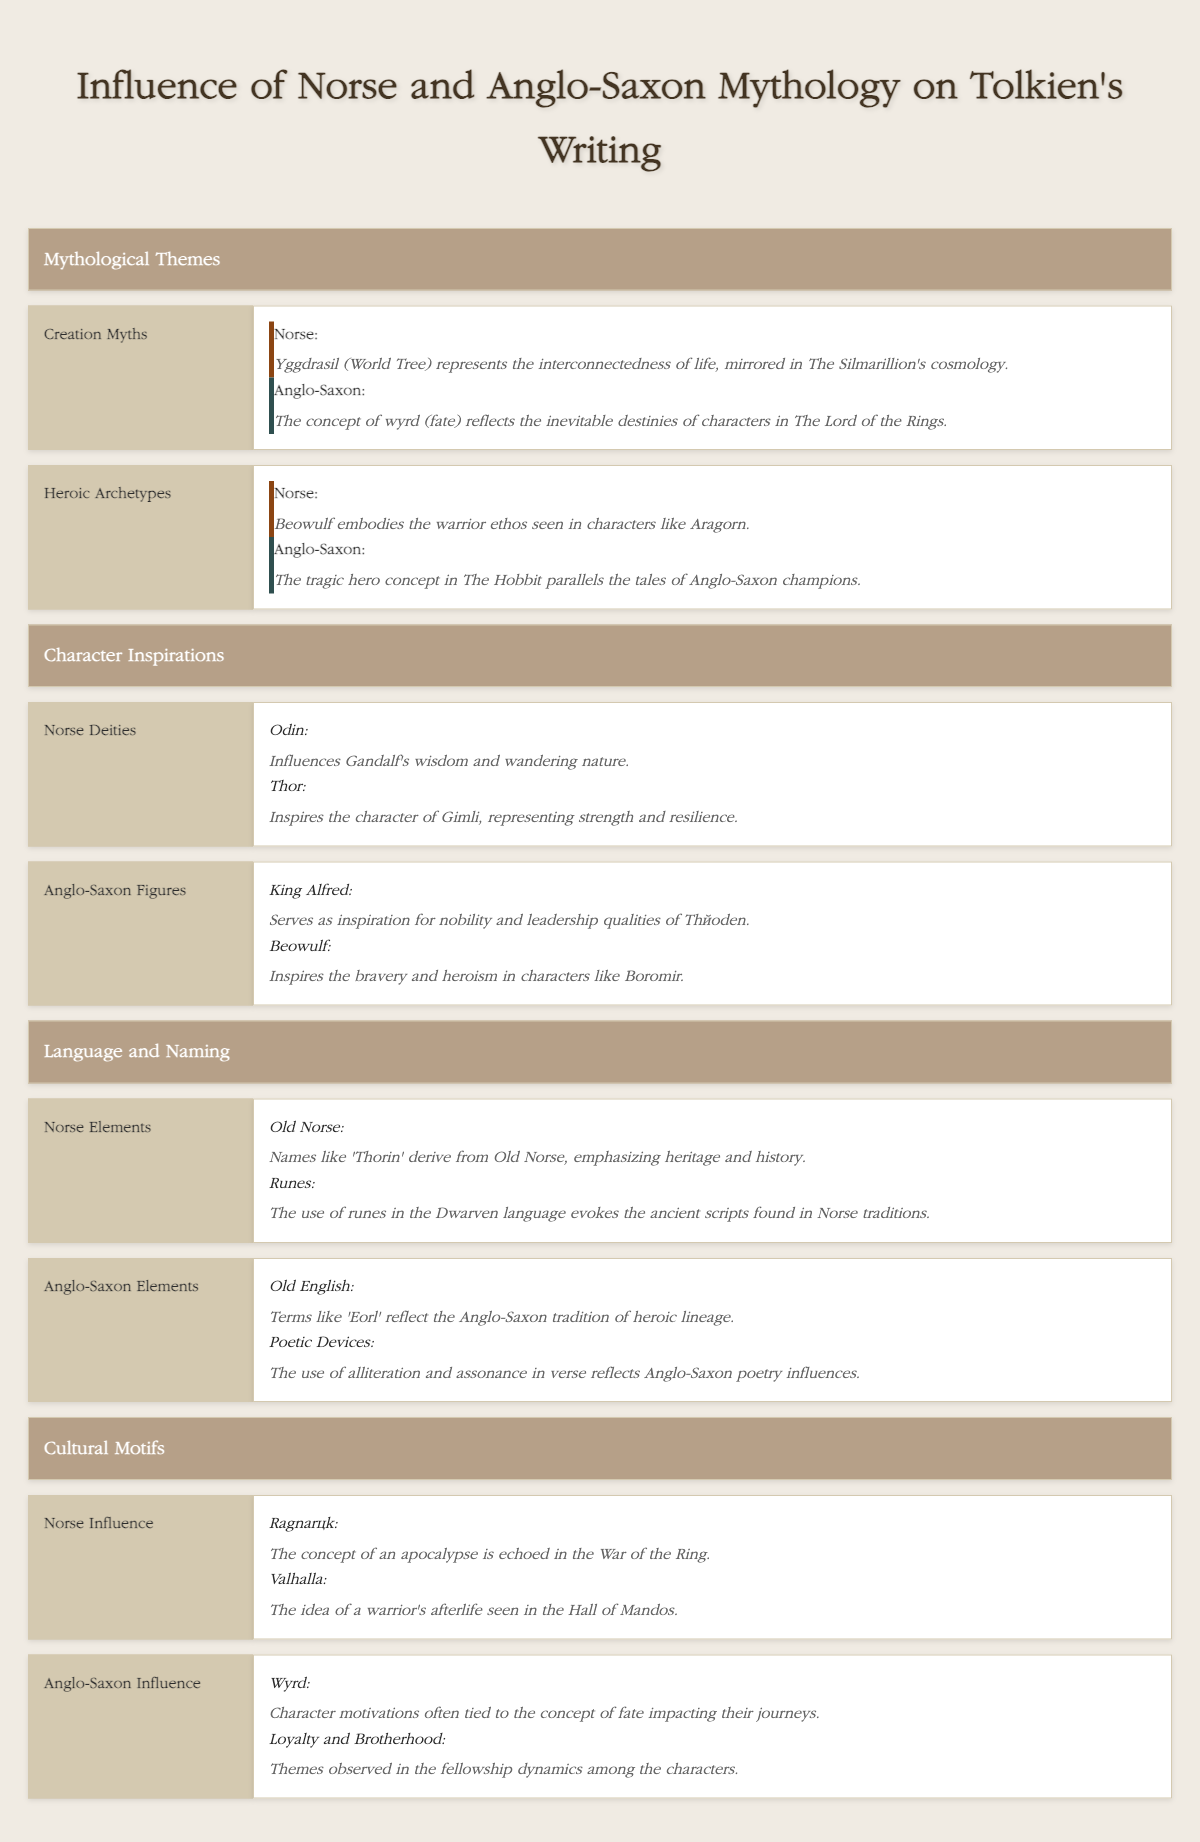What are the Norse influences in the concept of Creation Myths? According to the table, Norse influences include Yggdrasil (World Tree) which represents interconnectedness of life in The Silmarillion's cosmology.
Answer: Yggdrasil represents interconnectedness of life What character in Tolkien's work exemplifies the warrior ethos found in Norse mythology? The table indicates that Beowulf embodies the warrior ethos, which is mirrored in the character of Aragorn in Tolkien's work.
Answer: Aragorn Does the concept of wyrd influence any character motivations in Tolkien's writing? Yes, the table states that the concept of wyrd ties character motivations to fate, indicating that it affects their journeys.
Answer: Yes Which Anglo-Saxon figure inspired the character of Théoden? The table specifies that King Alfred serves as inspiration for the nobility and leadership qualities of Théoden.
Answer: King Alfred What are the two main Norse elements in Tolkien's language and naming found in the table? The table mentions Old Norse as a source for names like 'Thorin' emphasizing heritage and history, and also the use of runes in the Dwarven language evoking ancient scripts.
Answer: Old Norse and Runes In terms of cultural motifs, what concept from Norse mythology is echoed in the War of the Ring? The table illustrates that the concept of Ragnarök, often associated with apocalypse, is echoed in the War of the Ring.
Answer: Ragnarök Which heroic archetype in Norse mythology is reflected in The Hobbit? The table indicates that the tragic hero concept in The Hobbit parallels the tales of Anglo-Saxon champions, thus linking to Anglo-Saxon heroic archetypes.
Answer: Tragic hero concept Are loyalty and brotherhood themes present in Tolkien's narrative drawing from Anglo-Saxon influence? The table confirms that themes of loyalty and brotherhood are observed in the fellowship dynamics among the characters, indicating their presence.
Answer: Yes What is the main significance of using poetic devices from Anglo-Saxon traditions in Tolkien's work? The table notes that the use of alliteration and assonance reflects Anglo-Saxon poetry influences, which contributes to the stylistic richness of Tolkien's writing.
Answer: Stylistic richness Summarize the primary differences between Norse and Anglo-Saxon influences on character inspirations in Tolkien's writing. The Norse influences focus on deities such as Odin and Thor, impacting characters like Gandalf and Gimli, while Anglo-Saxon inspirations derive from figures like King Alfred and Beowulf, affecting characters like Théoden and Boromir. The answer here requires comparing different inspirations from each mythology and identifying their unique influences.
Answer: Norse: deities; Anglo-Saxon: historical figures 